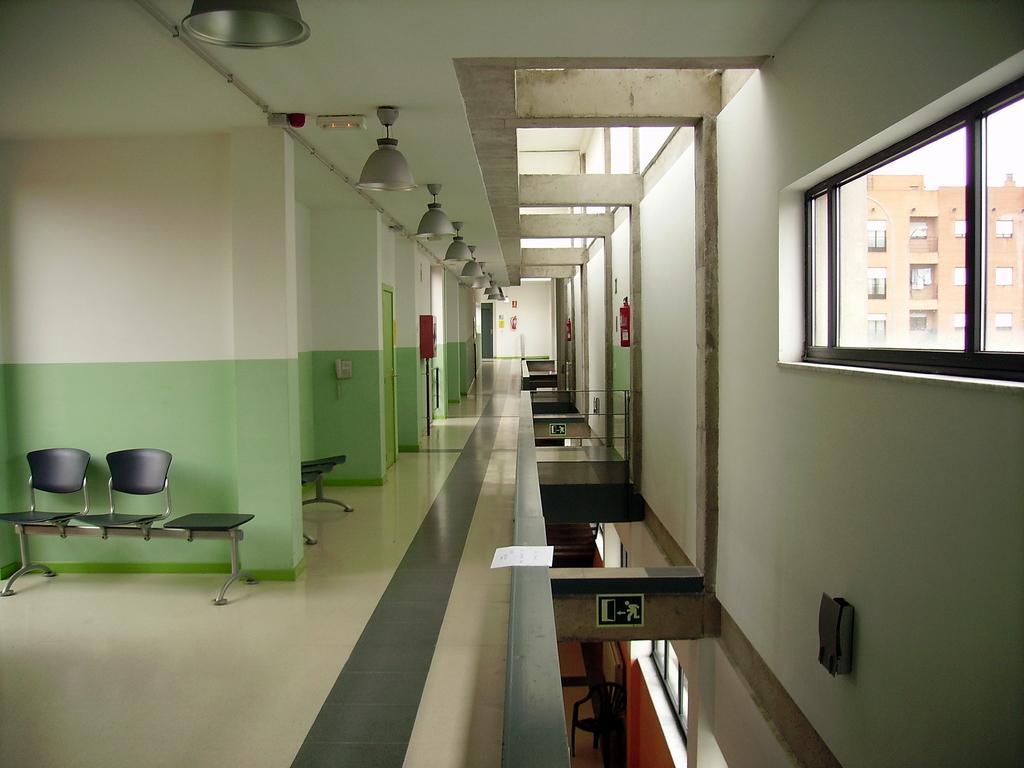What type of furniture can be seen in the image? There are chairs in the image. What architectural feature is present in the image? There is a fence in the image. What other architectural feature can be seen in the image? There is a wall in the image. What can be seen through the wall in the image? There are windows in the image. What type of lighting is present in the image? There are lamps in the image. Where was the image taken? The image was taken in a building. What type of collar can be seen on the wall in the image? There is no collar present on the wall in the image. Can you describe the dress worn by the lamp in the image? There is no dress present on the lamp in the image, as lamps do not wear clothing. 